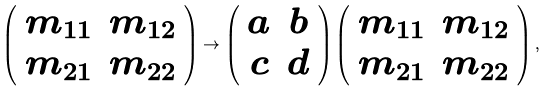Convert formula to latex. <formula><loc_0><loc_0><loc_500><loc_500>\left ( \begin{array} { c c } m _ { 1 1 } & m _ { 1 2 } \\ m _ { 2 1 } & m _ { 2 2 } \end{array} \right ) \to \left ( \begin{array} { c c } a & b \\ c & d \end{array} \right ) \left ( \begin{array} { c c } m _ { 1 1 } & m _ { 1 2 } \\ m _ { 2 1 } & m _ { 2 2 } \end{array} \right ) ,</formula> 